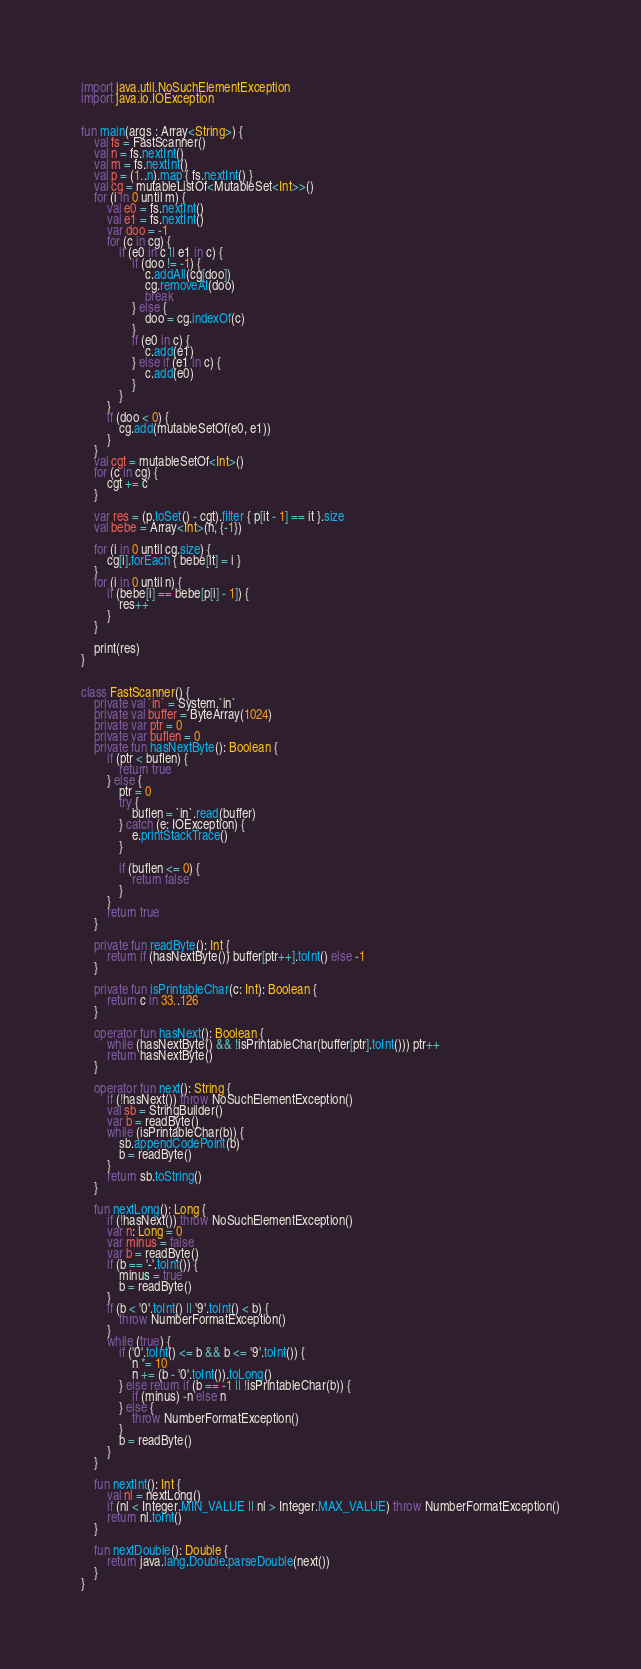Convert code to text. <code><loc_0><loc_0><loc_500><loc_500><_Kotlin_>
import java.util.NoSuchElementException
import java.io.IOException


fun main(args : Array<String>) {
    val fs = FastScanner()
    val n = fs.nextInt()
    val m = fs.nextInt()
    val p = (1..n).map { fs.nextInt() }
    val cg = mutableListOf<MutableSet<Int>>()
    for (i in 0 until m) {
        val e0 = fs.nextInt()
        val e1 = fs.nextInt()
        var doo = -1
        for (c in cg) {
            if (e0 in c || e1 in c) {
                if (doo != -1) {
                    c.addAll(cg[doo])
                    cg.removeAt(doo)
                    break
                } else {
                    doo = cg.indexOf(c)
                }
                if (e0 in c) {
                    c.add(e1)
                } else if (e1 in c) {
                    c.add(e0)
                }
            }
        }
        if (doo < 0) {
            cg.add(mutableSetOf(e0, e1))
        }
    }
    val cgt = mutableSetOf<Int>()
    for (c in cg) {
        cgt += c
    }

    var res = (p.toSet() - cgt).filter { p[it - 1] == it }.size
    val bebe = Array<Int>(n, {-1})

    for (i in 0 until cg.size) {
        cg[i].forEach { bebe[it] = i }
    }
    for (i in 0 until n) {
        if (bebe[i] == bebe[p[i] - 1]) {
            res++
        }
    }

    print(res)
}


class FastScanner() {
    private val `in` = System.`in`
    private val buffer = ByteArray(1024)
    private var ptr = 0
    private var buflen = 0
    private fun hasNextByte(): Boolean {
        if (ptr < buflen) {
            return true
        } else {
            ptr = 0
            try {
                buflen = `in`.read(buffer)
            } catch (e: IOException) {
                e.printStackTrace()
            }

            if (buflen <= 0) {
                return false
            }
        }
        return true
    }

    private fun readByte(): Int {
        return if (hasNextByte()) buffer[ptr++].toInt() else -1
    }

    private fun isPrintableChar(c: Int): Boolean {
        return c in 33..126
    }

    operator fun hasNext(): Boolean {
        while (hasNextByte() && !isPrintableChar(buffer[ptr].toInt())) ptr++
        return hasNextByte()
    }

    operator fun next(): String {
        if (!hasNext()) throw NoSuchElementException()
        val sb = StringBuilder()
        var b = readByte()
        while (isPrintableChar(b)) {
            sb.appendCodePoint(b)
            b = readByte()
        }
        return sb.toString()
    }

    fun nextLong(): Long {
        if (!hasNext()) throw NoSuchElementException()
        var n: Long = 0
        var minus = false
        var b = readByte()
        if (b == '-'.toInt()) {
            minus = true
            b = readByte()
        }
        if (b < '0'.toInt() || '9'.toInt() < b) {
            throw NumberFormatException()
        }
        while (true) {
            if ('0'.toInt() <= b && b <= '9'.toInt()) {
                n *= 10
                n += (b - '0'.toInt()).toLong()
            } else return if (b == -1 || !isPrintableChar(b)) {
                if (minus) -n else n
            } else {
                throw NumberFormatException()
            }
            b = readByte()
        }
    }

    fun nextInt(): Int {
        val nl = nextLong()
        if (nl < Integer.MIN_VALUE || nl > Integer.MAX_VALUE) throw NumberFormatException()
        return nl.toInt()
    }

    fun nextDouble(): Double {
        return java.lang.Double.parseDouble(next())
    }
}</code> 